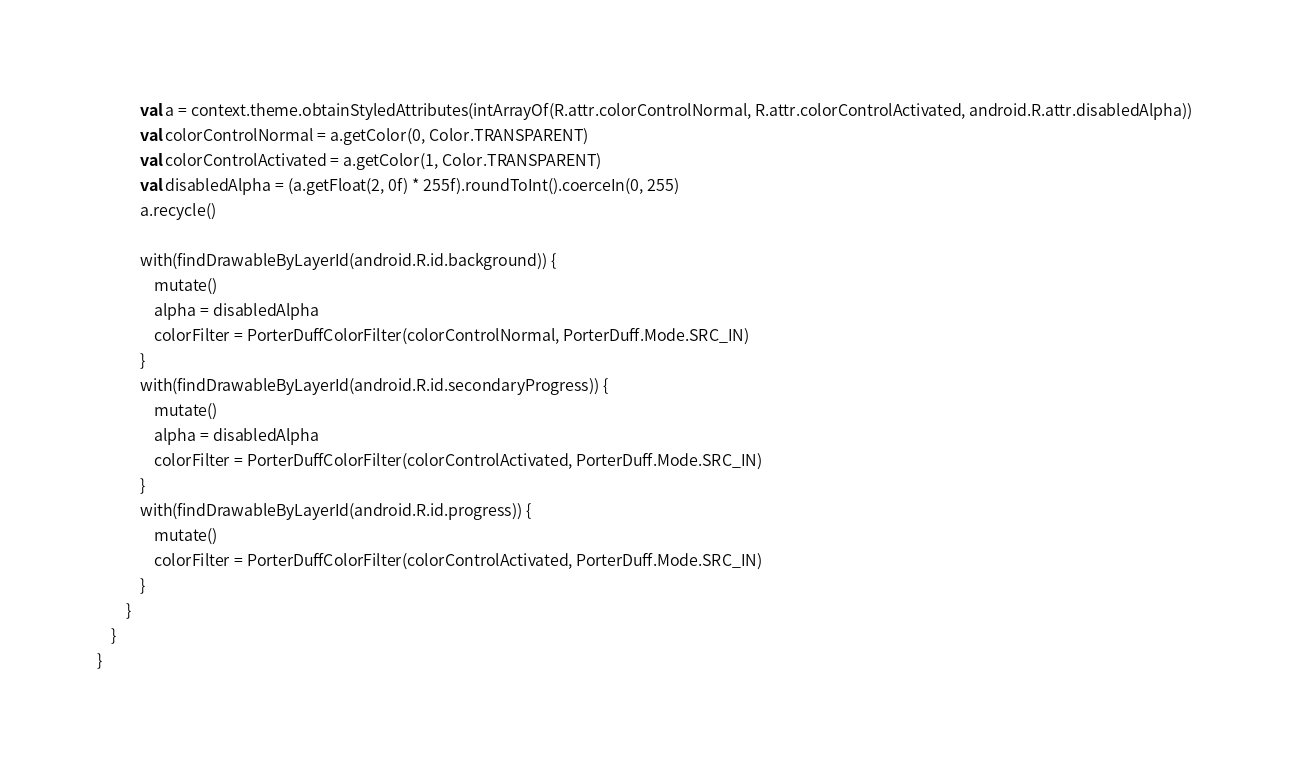<code> <loc_0><loc_0><loc_500><loc_500><_Kotlin_>            val a = context.theme.obtainStyledAttributes(intArrayOf(R.attr.colorControlNormal, R.attr.colorControlActivated, android.R.attr.disabledAlpha))
            val colorControlNormal = a.getColor(0, Color.TRANSPARENT)
            val colorControlActivated = a.getColor(1, Color.TRANSPARENT)
            val disabledAlpha = (a.getFloat(2, 0f) * 255f).roundToInt().coerceIn(0, 255)
            a.recycle()

            with(findDrawableByLayerId(android.R.id.background)) {
                mutate()
                alpha = disabledAlpha
                colorFilter = PorterDuffColorFilter(colorControlNormal, PorterDuff.Mode.SRC_IN)
            }
            with(findDrawableByLayerId(android.R.id.secondaryProgress)) {
                mutate()
                alpha = disabledAlpha
                colorFilter = PorterDuffColorFilter(colorControlActivated, PorterDuff.Mode.SRC_IN)
            }
            with(findDrawableByLayerId(android.R.id.progress)) {
                mutate()
                colorFilter = PorterDuffColorFilter(colorControlActivated, PorterDuff.Mode.SRC_IN)
            }
        }
    }
}</code> 